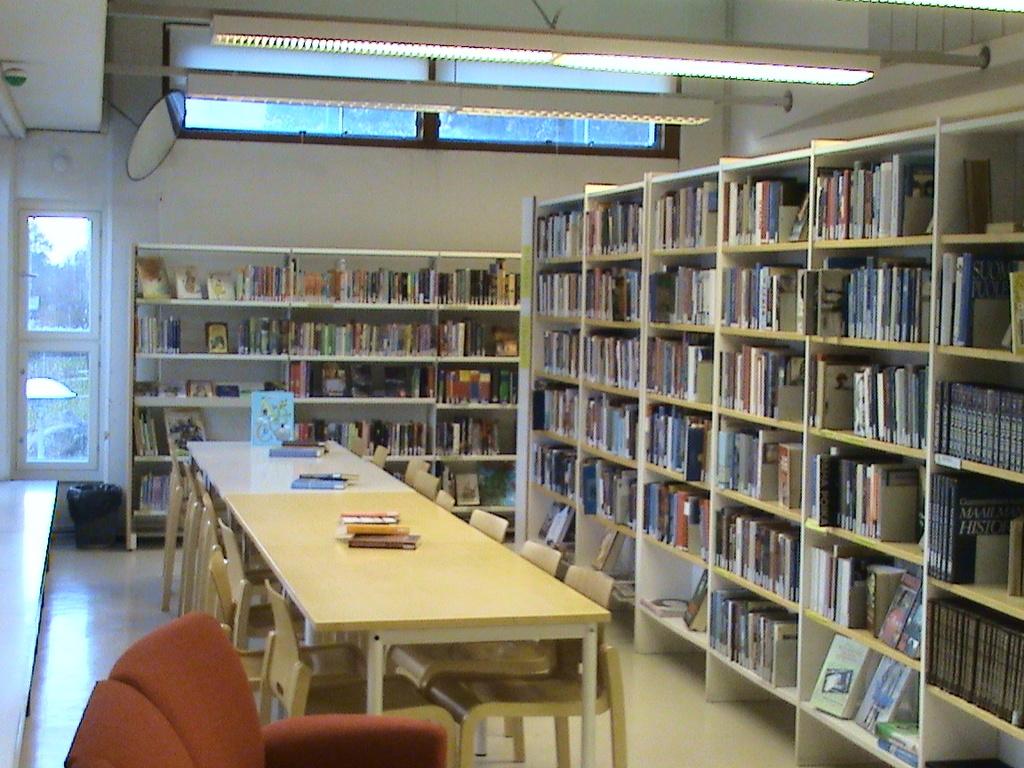Is this a library?
Offer a very short reply. Answering does not require reading text in the image. 